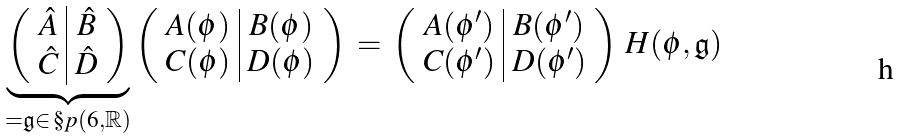Convert formula to latex. <formula><loc_0><loc_0><loc_500><loc_500>\underbrace { \left ( \begin{array} { c | c } { \hat { A } } & { \hat { B } } \\ { \hat { C } } & { \hat { D } } \end{array} \right ) } _ { = \mathfrak { g } \in \, \S p ( 6 , \mathbb { R } ) } \left ( \begin{array} { c | c } { A } ( \phi ) & { B } ( \phi ) \\ { C } ( \phi ) & { D } ( \phi ) \end{array} \right ) \, = \, \left ( \begin{array} { c | c } { A } ( \phi ^ { \prime } ) & { B } ( \phi ^ { \prime } ) \\ { C } ( \phi ^ { \prime } ) & { D } ( \phi ^ { \prime } ) \end{array} \right ) \, H ( \phi , \mathfrak { g } )</formula> 